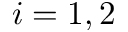<formula> <loc_0><loc_0><loc_500><loc_500>i = 1 , 2</formula> 